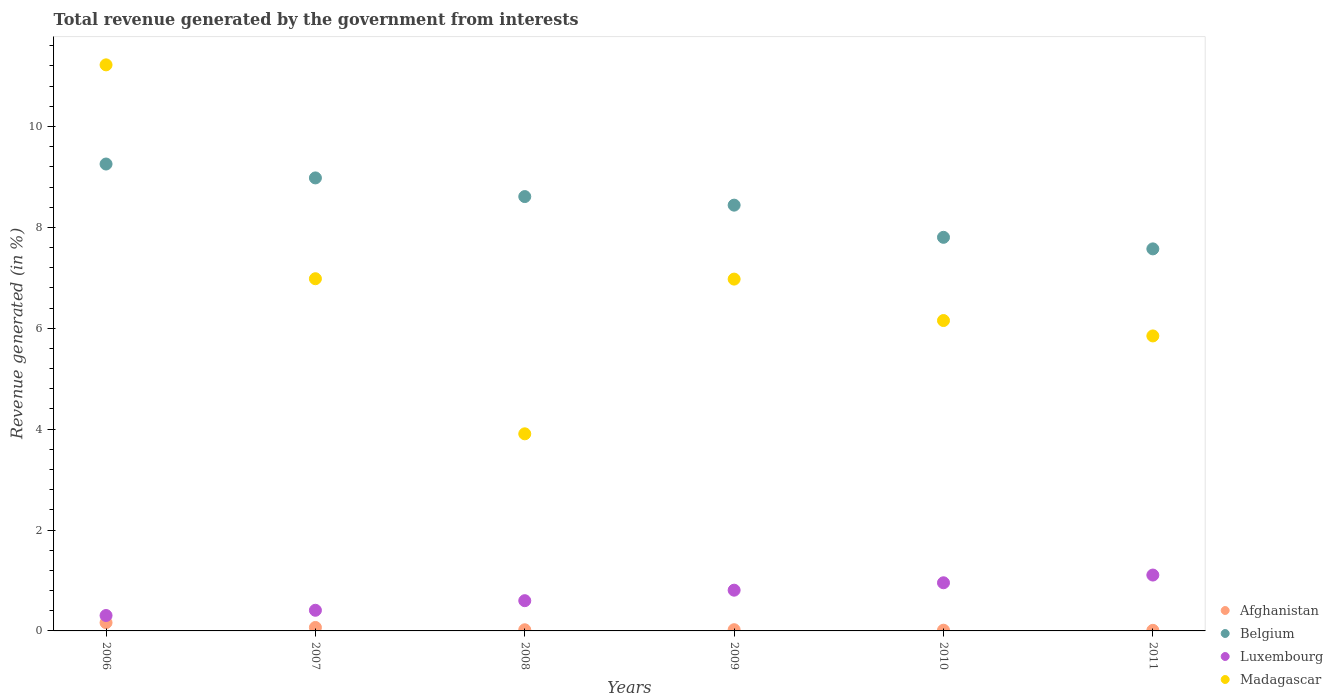What is the total revenue generated in Madagascar in 2008?
Your answer should be compact. 3.91. Across all years, what is the maximum total revenue generated in Madagascar?
Your answer should be very brief. 11.22. Across all years, what is the minimum total revenue generated in Belgium?
Keep it short and to the point. 7.57. In which year was the total revenue generated in Luxembourg maximum?
Your answer should be very brief. 2011. In which year was the total revenue generated in Madagascar minimum?
Provide a succinct answer. 2008. What is the total total revenue generated in Luxembourg in the graph?
Offer a very short reply. 4.18. What is the difference between the total revenue generated in Belgium in 2006 and that in 2011?
Make the answer very short. 1.68. What is the difference between the total revenue generated in Afghanistan in 2009 and the total revenue generated in Madagascar in 2008?
Keep it short and to the point. -3.88. What is the average total revenue generated in Afghanistan per year?
Ensure brevity in your answer.  0.05. In the year 2009, what is the difference between the total revenue generated in Belgium and total revenue generated in Luxembourg?
Ensure brevity in your answer.  7.63. In how many years, is the total revenue generated in Luxembourg greater than 2.4 %?
Offer a very short reply. 0. What is the ratio of the total revenue generated in Madagascar in 2006 to that in 2009?
Provide a succinct answer. 1.61. Is the total revenue generated in Belgium in 2009 less than that in 2011?
Provide a short and direct response. No. Is the difference between the total revenue generated in Belgium in 2006 and 2007 greater than the difference between the total revenue generated in Luxembourg in 2006 and 2007?
Make the answer very short. Yes. What is the difference between the highest and the second highest total revenue generated in Madagascar?
Ensure brevity in your answer.  4.24. What is the difference between the highest and the lowest total revenue generated in Belgium?
Your answer should be compact. 1.68. In how many years, is the total revenue generated in Belgium greater than the average total revenue generated in Belgium taken over all years?
Keep it short and to the point. 3. Is the sum of the total revenue generated in Belgium in 2008 and 2009 greater than the maximum total revenue generated in Luxembourg across all years?
Ensure brevity in your answer.  Yes. Is it the case that in every year, the sum of the total revenue generated in Madagascar and total revenue generated in Afghanistan  is greater than the sum of total revenue generated in Luxembourg and total revenue generated in Belgium?
Offer a very short reply. Yes. Does the total revenue generated in Belgium monotonically increase over the years?
Offer a terse response. No. Is the total revenue generated in Luxembourg strictly greater than the total revenue generated in Belgium over the years?
Provide a succinct answer. No. How many dotlines are there?
Provide a short and direct response. 4. How many years are there in the graph?
Provide a succinct answer. 6. What is the difference between two consecutive major ticks on the Y-axis?
Make the answer very short. 2. Are the values on the major ticks of Y-axis written in scientific E-notation?
Offer a very short reply. No. Does the graph contain grids?
Offer a terse response. No. Where does the legend appear in the graph?
Provide a succinct answer. Bottom right. What is the title of the graph?
Offer a very short reply. Total revenue generated by the government from interests. What is the label or title of the Y-axis?
Your response must be concise. Revenue generated (in %). What is the Revenue generated (in %) in Afghanistan in 2006?
Your answer should be compact. 0.16. What is the Revenue generated (in %) in Belgium in 2006?
Make the answer very short. 9.26. What is the Revenue generated (in %) of Luxembourg in 2006?
Your response must be concise. 0.31. What is the Revenue generated (in %) in Madagascar in 2006?
Keep it short and to the point. 11.22. What is the Revenue generated (in %) of Afghanistan in 2007?
Offer a terse response. 0.07. What is the Revenue generated (in %) of Belgium in 2007?
Your answer should be very brief. 8.98. What is the Revenue generated (in %) of Luxembourg in 2007?
Your response must be concise. 0.41. What is the Revenue generated (in %) of Madagascar in 2007?
Provide a succinct answer. 6.98. What is the Revenue generated (in %) in Afghanistan in 2008?
Offer a very short reply. 0.02. What is the Revenue generated (in %) in Belgium in 2008?
Ensure brevity in your answer.  8.61. What is the Revenue generated (in %) in Luxembourg in 2008?
Your response must be concise. 0.6. What is the Revenue generated (in %) of Madagascar in 2008?
Make the answer very short. 3.91. What is the Revenue generated (in %) in Afghanistan in 2009?
Provide a short and direct response. 0.02. What is the Revenue generated (in %) of Belgium in 2009?
Keep it short and to the point. 8.44. What is the Revenue generated (in %) of Luxembourg in 2009?
Your response must be concise. 0.81. What is the Revenue generated (in %) of Madagascar in 2009?
Give a very brief answer. 6.98. What is the Revenue generated (in %) of Afghanistan in 2010?
Ensure brevity in your answer.  0.01. What is the Revenue generated (in %) of Belgium in 2010?
Provide a short and direct response. 7.8. What is the Revenue generated (in %) of Luxembourg in 2010?
Your response must be concise. 0.95. What is the Revenue generated (in %) in Madagascar in 2010?
Provide a succinct answer. 6.15. What is the Revenue generated (in %) of Afghanistan in 2011?
Keep it short and to the point. 0.01. What is the Revenue generated (in %) of Belgium in 2011?
Your answer should be very brief. 7.57. What is the Revenue generated (in %) in Luxembourg in 2011?
Provide a short and direct response. 1.11. What is the Revenue generated (in %) of Madagascar in 2011?
Ensure brevity in your answer.  5.85. Across all years, what is the maximum Revenue generated (in %) of Afghanistan?
Keep it short and to the point. 0.16. Across all years, what is the maximum Revenue generated (in %) in Belgium?
Make the answer very short. 9.26. Across all years, what is the maximum Revenue generated (in %) of Luxembourg?
Your answer should be very brief. 1.11. Across all years, what is the maximum Revenue generated (in %) in Madagascar?
Provide a succinct answer. 11.22. Across all years, what is the minimum Revenue generated (in %) of Afghanistan?
Your response must be concise. 0.01. Across all years, what is the minimum Revenue generated (in %) in Belgium?
Provide a short and direct response. 7.57. Across all years, what is the minimum Revenue generated (in %) in Luxembourg?
Provide a short and direct response. 0.31. Across all years, what is the minimum Revenue generated (in %) of Madagascar?
Your answer should be very brief. 3.91. What is the total Revenue generated (in %) in Afghanistan in the graph?
Give a very brief answer. 0.31. What is the total Revenue generated (in %) of Belgium in the graph?
Make the answer very short. 50.67. What is the total Revenue generated (in %) of Luxembourg in the graph?
Provide a short and direct response. 4.18. What is the total Revenue generated (in %) of Madagascar in the graph?
Offer a very short reply. 41.09. What is the difference between the Revenue generated (in %) of Afghanistan in 2006 and that in 2007?
Offer a very short reply. 0.1. What is the difference between the Revenue generated (in %) in Belgium in 2006 and that in 2007?
Provide a short and direct response. 0.28. What is the difference between the Revenue generated (in %) in Luxembourg in 2006 and that in 2007?
Make the answer very short. -0.1. What is the difference between the Revenue generated (in %) in Madagascar in 2006 and that in 2007?
Offer a very short reply. 4.24. What is the difference between the Revenue generated (in %) in Afghanistan in 2006 and that in 2008?
Give a very brief answer. 0.14. What is the difference between the Revenue generated (in %) in Belgium in 2006 and that in 2008?
Offer a very short reply. 0.65. What is the difference between the Revenue generated (in %) in Luxembourg in 2006 and that in 2008?
Provide a short and direct response. -0.29. What is the difference between the Revenue generated (in %) in Madagascar in 2006 and that in 2008?
Make the answer very short. 7.32. What is the difference between the Revenue generated (in %) of Afghanistan in 2006 and that in 2009?
Keep it short and to the point. 0.14. What is the difference between the Revenue generated (in %) of Belgium in 2006 and that in 2009?
Make the answer very short. 0.82. What is the difference between the Revenue generated (in %) of Luxembourg in 2006 and that in 2009?
Give a very brief answer. -0.5. What is the difference between the Revenue generated (in %) of Madagascar in 2006 and that in 2009?
Ensure brevity in your answer.  4.25. What is the difference between the Revenue generated (in %) in Afghanistan in 2006 and that in 2010?
Offer a very short reply. 0.15. What is the difference between the Revenue generated (in %) in Belgium in 2006 and that in 2010?
Provide a succinct answer. 1.45. What is the difference between the Revenue generated (in %) in Luxembourg in 2006 and that in 2010?
Make the answer very short. -0.65. What is the difference between the Revenue generated (in %) of Madagascar in 2006 and that in 2010?
Make the answer very short. 5.07. What is the difference between the Revenue generated (in %) in Afghanistan in 2006 and that in 2011?
Provide a succinct answer. 0.15. What is the difference between the Revenue generated (in %) in Belgium in 2006 and that in 2011?
Provide a succinct answer. 1.68. What is the difference between the Revenue generated (in %) in Luxembourg in 2006 and that in 2011?
Provide a short and direct response. -0.8. What is the difference between the Revenue generated (in %) of Madagascar in 2006 and that in 2011?
Ensure brevity in your answer.  5.37. What is the difference between the Revenue generated (in %) of Afghanistan in 2007 and that in 2008?
Your response must be concise. 0.05. What is the difference between the Revenue generated (in %) in Belgium in 2007 and that in 2008?
Your answer should be compact. 0.37. What is the difference between the Revenue generated (in %) in Luxembourg in 2007 and that in 2008?
Offer a very short reply. -0.19. What is the difference between the Revenue generated (in %) in Madagascar in 2007 and that in 2008?
Your answer should be compact. 3.07. What is the difference between the Revenue generated (in %) of Afghanistan in 2007 and that in 2009?
Keep it short and to the point. 0.04. What is the difference between the Revenue generated (in %) in Belgium in 2007 and that in 2009?
Offer a very short reply. 0.54. What is the difference between the Revenue generated (in %) of Luxembourg in 2007 and that in 2009?
Your answer should be compact. -0.4. What is the difference between the Revenue generated (in %) in Madagascar in 2007 and that in 2009?
Keep it short and to the point. 0.01. What is the difference between the Revenue generated (in %) of Afghanistan in 2007 and that in 2010?
Keep it short and to the point. 0.05. What is the difference between the Revenue generated (in %) of Belgium in 2007 and that in 2010?
Give a very brief answer. 1.18. What is the difference between the Revenue generated (in %) of Luxembourg in 2007 and that in 2010?
Your answer should be compact. -0.55. What is the difference between the Revenue generated (in %) in Madagascar in 2007 and that in 2010?
Keep it short and to the point. 0.83. What is the difference between the Revenue generated (in %) of Afghanistan in 2007 and that in 2011?
Offer a very short reply. 0.06. What is the difference between the Revenue generated (in %) in Belgium in 2007 and that in 2011?
Give a very brief answer. 1.41. What is the difference between the Revenue generated (in %) in Luxembourg in 2007 and that in 2011?
Keep it short and to the point. -0.7. What is the difference between the Revenue generated (in %) in Madagascar in 2007 and that in 2011?
Make the answer very short. 1.13. What is the difference between the Revenue generated (in %) in Afghanistan in 2008 and that in 2009?
Keep it short and to the point. -0. What is the difference between the Revenue generated (in %) of Belgium in 2008 and that in 2009?
Offer a terse response. 0.17. What is the difference between the Revenue generated (in %) of Luxembourg in 2008 and that in 2009?
Make the answer very short. -0.21. What is the difference between the Revenue generated (in %) in Madagascar in 2008 and that in 2009?
Keep it short and to the point. -3.07. What is the difference between the Revenue generated (in %) in Afghanistan in 2008 and that in 2010?
Offer a very short reply. 0.01. What is the difference between the Revenue generated (in %) of Belgium in 2008 and that in 2010?
Your answer should be compact. 0.81. What is the difference between the Revenue generated (in %) of Luxembourg in 2008 and that in 2010?
Your response must be concise. -0.35. What is the difference between the Revenue generated (in %) of Madagascar in 2008 and that in 2010?
Offer a very short reply. -2.25. What is the difference between the Revenue generated (in %) of Afghanistan in 2008 and that in 2011?
Ensure brevity in your answer.  0.01. What is the difference between the Revenue generated (in %) in Belgium in 2008 and that in 2011?
Make the answer very short. 1.04. What is the difference between the Revenue generated (in %) in Luxembourg in 2008 and that in 2011?
Offer a very short reply. -0.51. What is the difference between the Revenue generated (in %) of Madagascar in 2008 and that in 2011?
Ensure brevity in your answer.  -1.94. What is the difference between the Revenue generated (in %) of Afghanistan in 2009 and that in 2010?
Provide a short and direct response. 0.01. What is the difference between the Revenue generated (in %) in Belgium in 2009 and that in 2010?
Your answer should be compact. 0.64. What is the difference between the Revenue generated (in %) in Luxembourg in 2009 and that in 2010?
Offer a terse response. -0.15. What is the difference between the Revenue generated (in %) in Madagascar in 2009 and that in 2010?
Offer a terse response. 0.82. What is the difference between the Revenue generated (in %) in Afghanistan in 2009 and that in 2011?
Make the answer very short. 0.01. What is the difference between the Revenue generated (in %) of Belgium in 2009 and that in 2011?
Provide a succinct answer. 0.87. What is the difference between the Revenue generated (in %) in Luxembourg in 2009 and that in 2011?
Offer a very short reply. -0.3. What is the difference between the Revenue generated (in %) of Madagascar in 2009 and that in 2011?
Your answer should be compact. 1.13. What is the difference between the Revenue generated (in %) in Afghanistan in 2010 and that in 2011?
Keep it short and to the point. 0. What is the difference between the Revenue generated (in %) in Belgium in 2010 and that in 2011?
Provide a short and direct response. 0.23. What is the difference between the Revenue generated (in %) in Luxembourg in 2010 and that in 2011?
Provide a short and direct response. -0.15. What is the difference between the Revenue generated (in %) in Madagascar in 2010 and that in 2011?
Ensure brevity in your answer.  0.3. What is the difference between the Revenue generated (in %) of Afghanistan in 2006 and the Revenue generated (in %) of Belgium in 2007?
Provide a short and direct response. -8.82. What is the difference between the Revenue generated (in %) in Afghanistan in 2006 and the Revenue generated (in %) in Luxembourg in 2007?
Give a very brief answer. -0.25. What is the difference between the Revenue generated (in %) in Afghanistan in 2006 and the Revenue generated (in %) in Madagascar in 2007?
Offer a terse response. -6.82. What is the difference between the Revenue generated (in %) of Belgium in 2006 and the Revenue generated (in %) of Luxembourg in 2007?
Offer a very short reply. 8.85. What is the difference between the Revenue generated (in %) in Belgium in 2006 and the Revenue generated (in %) in Madagascar in 2007?
Ensure brevity in your answer.  2.27. What is the difference between the Revenue generated (in %) in Luxembourg in 2006 and the Revenue generated (in %) in Madagascar in 2007?
Ensure brevity in your answer.  -6.68. What is the difference between the Revenue generated (in %) in Afghanistan in 2006 and the Revenue generated (in %) in Belgium in 2008?
Ensure brevity in your answer.  -8.45. What is the difference between the Revenue generated (in %) of Afghanistan in 2006 and the Revenue generated (in %) of Luxembourg in 2008?
Offer a terse response. -0.44. What is the difference between the Revenue generated (in %) of Afghanistan in 2006 and the Revenue generated (in %) of Madagascar in 2008?
Your answer should be compact. -3.74. What is the difference between the Revenue generated (in %) in Belgium in 2006 and the Revenue generated (in %) in Luxembourg in 2008?
Offer a terse response. 8.66. What is the difference between the Revenue generated (in %) of Belgium in 2006 and the Revenue generated (in %) of Madagascar in 2008?
Ensure brevity in your answer.  5.35. What is the difference between the Revenue generated (in %) in Luxembourg in 2006 and the Revenue generated (in %) in Madagascar in 2008?
Make the answer very short. -3.6. What is the difference between the Revenue generated (in %) in Afghanistan in 2006 and the Revenue generated (in %) in Belgium in 2009?
Make the answer very short. -8.28. What is the difference between the Revenue generated (in %) of Afghanistan in 2006 and the Revenue generated (in %) of Luxembourg in 2009?
Give a very brief answer. -0.64. What is the difference between the Revenue generated (in %) in Afghanistan in 2006 and the Revenue generated (in %) in Madagascar in 2009?
Keep it short and to the point. -6.81. What is the difference between the Revenue generated (in %) in Belgium in 2006 and the Revenue generated (in %) in Luxembourg in 2009?
Offer a terse response. 8.45. What is the difference between the Revenue generated (in %) in Belgium in 2006 and the Revenue generated (in %) in Madagascar in 2009?
Your answer should be very brief. 2.28. What is the difference between the Revenue generated (in %) in Luxembourg in 2006 and the Revenue generated (in %) in Madagascar in 2009?
Offer a very short reply. -6.67. What is the difference between the Revenue generated (in %) of Afghanistan in 2006 and the Revenue generated (in %) of Belgium in 2010?
Provide a succinct answer. -7.64. What is the difference between the Revenue generated (in %) of Afghanistan in 2006 and the Revenue generated (in %) of Luxembourg in 2010?
Give a very brief answer. -0.79. What is the difference between the Revenue generated (in %) of Afghanistan in 2006 and the Revenue generated (in %) of Madagascar in 2010?
Give a very brief answer. -5.99. What is the difference between the Revenue generated (in %) of Belgium in 2006 and the Revenue generated (in %) of Luxembourg in 2010?
Provide a succinct answer. 8.3. What is the difference between the Revenue generated (in %) in Belgium in 2006 and the Revenue generated (in %) in Madagascar in 2010?
Your answer should be very brief. 3.1. What is the difference between the Revenue generated (in %) of Luxembourg in 2006 and the Revenue generated (in %) of Madagascar in 2010?
Make the answer very short. -5.85. What is the difference between the Revenue generated (in %) in Afghanistan in 2006 and the Revenue generated (in %) in Belgium in 2011?
Your response must be concise. -7.41. What is the difference between the Revenue generated (in %) in Afghanistan in 2006 and the Revenue generated (in %) in Luxembourg in 2011?
Provide a succinct answer. -0.94. What is the difference between the Revenue generated (in %) of Afghanistan in 2006 and the Revenue generated (in %) of Madagascar in 2011?
Make the answer very short. -5.68. What is the difference between the Revenue generated (in %) of Belgium in 2006 and the Revenue generated (in %) of Luxembourg in 2011?
Make the answer very short. 8.15. What is the difference between the Revenue generated (in %) in Belgium in 2006 and the Revenue generated (in %) in Madagascar in 2011?
Your response must be concise. 3.41. What is the difference between the Revenue generated (in %) in Luxembourg in 2006 and the Revenue generated (in %) in Madagascar in 2011?
Ensure brevity in your answer.  -5.54. What is the difference between the Revenue generated (in %) of Afghanistan in 2007 and the Revenue generated (in %) of Belgium in 2008?
Offer a terse response. -8.54. What is the difference between the Revenue generated (in %) in Afghanistan in 2007 and the Revenue generated (in %) in Luxembourg in 2008?
Offer a terse response. -0.53. What is the difference between the Revenue generated (in %) in Afghanistan in 2007 and the Revenue generated (in %) in Madagascar in 2008?
Offer a very short reply. -3.84. What is the difference between the Revenue generated (in %) of Belgium in 2007 and the Revenue generated (in %) of Luxembourg in 2008?
Make the answer very short. 8.38. What is the difference between the Revenue generated (in %) of Belgium in 2007 and the Revenue generated (in %) of Madagascar in 2008?
Your response must be concise. 5.07. What is the difference between the Revenue generated (in %) in Luxembourg in 2007 and the Revenue generated (in %) in Madagascar in 2008?
Offer a terse response. -3.5. What is the difference between the Revenue generated (in %) of Afghanistan in 2007 and the Revenue generated (in %) of Belgium in 2009?
Provide a short and direct response. -8.37. What is the difference between the Revenue generated (in %) of Afghanistan in 2007 and the Revenue generated (in %) of Luxembourg in 2009?
Make the answer very short. -0.74. What is the difference between the Revenue generated (in %) of Afghanistan in 2007 and the Revenue generated (in %) of Madagascar in 2009?
Your answer should be compact. -6.91. What is the difference between the Revenue generated (in %) in Belgium in 2007 and the Revenue generated (in %) in Luxembourg in 2009?
Your response must be concise. 8.17. What is the difference between the Revenue generated (in %) in Belgium in 2007 and the Revenue generated (in %) in Madagascar in 2009?
Give a very brief answer. 2.01. What is the difference between the Revenue generated (in %) of Luxembourg in 2007 and the Revenue generated (in %) of Madagascar in 2009?
Ensure brevity in your answer.  -6.57. What is the difference between the Revenue generated (in %) in Afghanistan in 2007 and the Revenue generated (in %) in Belgium in 2010?
Keep it short and to the point. -7.73. What is the difference between the Revenue generated (in %) of Afghanistan in 2007 and the Revenue generated (in %) of Luxembourg in 2010?
Make the answer very short. -0.89. What is the difference between the Revenue generated (in %) of Afghanistan in 2007 and the Revenue generated (in %) of Madagascar in 2010?
Ensure brevity in your answer.  -6.08. What is the difference between the Revenue generated (in %) of Belgium in 2007 and the Revenue generated (in %) of Luxembourg in 2010?
Your answer should be very brief. 8.03. What is the difference between the Revenue generated (in %) of Belgium in 2007 and the Revenue generated (in %) of Madagascar in 2010?
Your response must be concise. 2.83. What is the difference between the Revenue generated (in %) in Luxembourg in 2007 and the Revenue generated (in %) in Madagascar in 2010?
Give a very brief answer. -5.74. What is the difference between the Revenue generated (in %) of Afghanistan in 2007 and the Revenue generated (in %) of Belgium in 2011?
Ensure brevity in your answer.  -7.51. What is the difference between the Revenue generated (in %) in Afghanistan in 2007 and the Revenue generated (in %) in Luxembourg in 2011?
Keep it short and to the point. -1.04. What is the difference between the Revenue generated (in %) in Afghanistan in 2007 and the Revenue generated (in %) in Madagascar in 2011?
Your response must be concise. -5.78. What is the difference between the Revenue generated (in %) in Belgium in 2007 and the Revenue generated (in %) in Luxembourg in 2011?
Offer a terse response. 7.87. What is the difference between the Revenue generated (in %) of Belgium in 2007 and the Revenue generated (in %) of Madagascar in 2011?
Your response must be concise. 3.13. What is the difference between the Revenue generated (in %) of Luxembourg in 2007 and the Revenue generated (in %) of Madagascar in 2011?
Ensure brevity in your answer.  -5.44. What is the difference between the Revenue generated (in %) of Afghanistan in 2008 and the Revenue generated (in %) of Belgium in 2009?
Provide a succinct answer. -8.42. What is the difference between the Revenue generated (in %) of Afghanistan in 2008 and the Revenue generated (in %) of Luxembourg in 2009?
Your answer should be compact. -0.78. What is the difference between the Revenue generated (in %) in Afghanistan in 2008 and the Revenue generated (in %) in Madagascar in 2009?
Make the answer very short. -6.95. What is the difference between the Revenue generated (in %) in Belgium in 2008 and the Revenue generated (in %) in Luxembourg in 2009?
Offer a terse response. 7.8. What is the difference between the Revenue generated (in %) in Belgium in 2008 and the Revenue generated (in %) in Madagascar in 2009?
Give a very brief answer. 1.64. What is the difference between the Revenue generated (in %) of Luxembourg in 2008 and the Revenue generated (in %) of Madagascar in 2009?
Keep it short and to the point. -6.38. What is the difference between the Revenue generated (in %) of Afghanistan in 2008 and the Revenue generated (in %) of Belgium in 2010?
Make the answer very short. -7.78. What is the difference between the Revenue generated (in %) in Afghanistan in 2008 and the Revenue generated (in %) in Luxembourg in 2010?
Provide a short and direct response. -0.93. What is the difference between the Revenue generated (in %) of Afghanistan in 2008 and the Revenue generated (in %) of Madagascar in 2010?
Provide a succinct answer. -6.13. What is the difference between the Revenue generated (in %) in Belgium in 2008 and the Revenue generated (in %) in Luxembourg in 2010?
Make the answer very short. 7.66. What is the difference between the Revenue generated (in %) in Belgium in 2008 and the Revenue generated (in %) in Madagascar in 2010?
Offer a very short reply. 2.46. What is the difference between the Revenue generated (in %) in Luxembourg in 2008 and the Revenue generated (in %) in Madagascar in 2010?
Make the answer very short. -5.55. What is the difference between the Revenue generated (in %) of Afghanistan in 2008 and the Revenue generated (in %) of Belgium in 2011?
Your response must be concise. -7.55. What is the difference between the Revenue generated (in %) in Afghanistan in 2008 and the Revenue generated (in %) in Luxembourg in 2011?
Keep it short and to the point. -1.08. What is the difference between the Revenue generated (in %) in Afghanistan in 2008 and the Revenue generated (in %) in Madagascar in 2011?
Ensure brevity in your answer.  -5.83. What is the difference between the Revenue generated (in %) of Belgium in 2008 and the Revenue generated (in %) of Luxembourg in 2011?
Provide a succinct answer. 7.5. What is the difference between the Revenue generated (in %) in Belgium in 2008 and the Revenue generated (in %) in Madagascar in 2011?
Provide a succinct answer. 2.76. What is the difference between the Revenue generated (in %) of Luxembourg in 2008 and the Revenue generated (in %) of Madagascar in 2011?
Offer a very short reply. -5.25. What is the difference between the Revenue generated (in %) of Afghanistan in 2009 and the Revenue generated (in %) of Belgium in 2010?
Give a very brief answer. -7.78. What is the difference between the Revenue generated (in %) of Afghanistan in 2009 and the Revenue generated (in %) of Luxembourg in 2010?
Provide a succinct answer. -0.93. What is the difference between the Revenue generated (in %) in Afghanistan in 2009 and the Revenue generated (in %) in Madagascar in 2010?
Ensure brevity in your answer.  -6.13. What is the difference between the Revenue generated (in %) in Belgium in 2009 and the Revenue generated (in %) in Luxembourg in 2010?
Give a very brief answer. 7.49. What is the difference between the Revenue generated (in %) in Belgium in 2009 and the Revenue generated (in %) in Madagascar in 2010?
Your answer should be very brief. 2.29. What is the difference between the Revenue generated (in %) in Luxembourg in 2009 and the Revenue generated (in %) in Madagascar in 2010?
Provide a succinct answer. -5.35. What is the difference between the Revenue generated (in %) in Afghanistan in 2009 and the Revenue generated (in %) in Belgium in 2011?
Give a very brief answer. -7.55. What is the difference between the Revenue generated (in %) in Afghanistan in 2009 and the Revenue generated (in %) in Luxembourg in 2011?
Give a very brief answer. -1.08. What is the difference between the Revenue generated (in %) of Afghanistan in 2009 and the Revenue generated (in %) of Madagascar in 2011?
Offer a very short reply. -5.82. What is the difference between the Revenue generated (in %) of Belgium in 2009 and the Revenue generated (in %) of Luxembourg in 2011?
Your answer should be very brief. 7.33. What is the difference between the Revenue generated (in %) in Belgium in 2009 and the Revenue generated (in %) in Madagascar in 2011?
Offer a terse response. 2.59. What is the difference between the Revenue generated (in %) of Luxembourg in 2009 and the Revenue generated (in %) of Madagascar in 2011?
Give a very brief answer. -5.04. What is the difference between the Revenue generated (in %) in Afghanistan in 2010 and the Revenue generated (in %) in Belgium in 2011?
Give a very brief answer. -7.56. What is the difference between the Revenue generated (in %) of Afghanistan in 2010 and the Revenue generated (in %) of Luxembourg in 2011?
Make the answer very short. -1.09. What is the difference between the Revenue generated (in %) in Afghanistan in 2010 and the Revenue generated (in %) in Madagascar in 2011?
Provide a succinct answer. -5.83. What is the difference between the Revenue generated (in %) in Belgium in 2010 and the Revenue generated (in %) in Luxembourg in 2011?
Your answer should be very brief. 6.7. What is the difference between the Revenue generated (in %) in Belgium in 2010 and the Revenue generated (in %) in Madagascar in 2011?
Your response must be concise. 1.95. What is the difference between the Revenue generated (in %) of Luxembourg in 2010 and the Revenue generated (in %) of Madagascar in 2011?
Your answer should be compact. -4.89. What is the average Revenue generated (in %) of Afghanistan per year?
Ensure brevity in your answer.  0.05. What is the average Revenue generated (in %) of Belgium per year?
Offer a very short reply. 8.44. What is the average Revenue generated (in %) in Luxembourg per year?
Ensure brevity in your answer.  0.7. What is the average Revenue generated (in %) of Madagascar per year?
Give a very brief answer. 6.85. In the year 2006, what is the difference between the Revenue generated (in %) of Afghanistan and Revenue generated (in %) of Belgium?
Your answer should be compact. -9.09. In the year 2006, what is the difference between the Revenue generated (in %) of Afghanistan and Revenue generated (in %) of Luxembourg?
Provide a succinct answer. -0.14. In the year 2006, what is the difference between the Revenue generated (in %) of Afghanistan and Revenue generated (in %) of Madagascar?
Provide a short and direct response. -11.06. In the year 2006, what is the difference between the Revenue generated (in %) of Belgium and Revenue generated (in %) of Luxembourg?
Keep it short and to the point. 8.95. In the year 2006, what is the difference between the Revenue generated (in %) in Belgium and Revenue generated (in %) in Madagascar?
Keep it short and to the point. -1.97. In the year 2006, what is the difference between the Revenue generated (in %) in Luxembourg and Revenue generated (in %) in Madagascar?
Your answer should be very brief. -10.92. In the year 2007, what is the difference between the Revenue generated (in %) of Afghanistan and Revenue generated (in %) of Belgium?
Provide a short and direct response. -8.91. In the year 2007, what is the difference between the Revenue generated (in %) in Afghanistan and Revenue generated (in %) in Luxembourg?
Offer a terse response. -0.34. In the year 2007, what is the difference between the Revenue generated (in %) in Afghanistan and Revenue generated (in %) in Madagascar?
Your response must be concise. -6.91. In the year 2007, what is the difference between the Revenue generated (in %) of Belgium and Revenue generated (in %) of Luxembourg?
Ensure brevity in your answer.  8.57. In the year 2007, what is the difference between the Revenue generated (in %) of Belgium and Revenue generated (in %) of Madagascar?
Provide a succinct answer. 2. In the year 2007, what is the difference between the Revenue generated (in %) of Luxembourg and Revenue generated (in %) of Madagascar?
Your answer should be very brief. -6.57. In the year 2008, what is the difference between the Revenue generated (in %) in Afghanistan and Revenue generated (in %) in Belgium?
Offer a terse response. -8.59. In the year 2008, what is the difference between the Revenue generated (in %) of Afghanistan and Revenue generated (in %) of Luxembourg?
Keep it short and to the point. -0.58. In the year 2008, what is the difference between the Revenue generated (in %) in Afghanistan and Revenue generated (in %) in Madagascar?
Your answer should be compact. -3.88. In the year 2008, what is the difference between the Revenue generated (in %) in Belgium and Revenue generated (in %) in Luxembourg?
Give a very brief answer. 8.01. In the year 2008, what is the difference between the Revenue generated (in %) in Belgium and Revenue generated (in %) in Madagascar?
Make the answer very short. 4.7. In the year 2008, what is the difference between the Revenue generated (in %) of Luxembourg and Revenue generated (in %) of Madagascar?
Offer a very short reply. -3.31. In the year 2009, what is the difference between the Revenue generated (in %) of Afghanistan and Revenue generated (in %) of Belgium?
Your answer should be very brief. -8.42. In the year 2009, what is the difference between the Revenue generated (in %) in Afghanistan and Revenue generated (in %) in Luxembourg?
Your answer should be very brief. -0.78. In the year 2009, what is the difference between the Revenue generated (in %) of Afghanistan and Revenue generated (in %) of Madagascar?
Offer a terse response. -6.95. In the year 2009, what is the difference between the Revenue generated (in %) in Belgium and Revenue generated (in %) in Luxembourg?
Your answer should be compact. 7.63. In the year 2009, what is the difference between the Revenue generated (in %) of Belgium and Revenue generated (in %) of Madagascar?
Your answer should be compact. 1.47. In the year 2009, what is the difference between the Revenue generated (in %) in Luxembourg and Revenue generated (in %) in Madagascar?
Your response must be concise. -6.17. In the year 2010, what is the difference between the Revenue generated (in %) in Afghanistan and Revenue generated (in %) in Belgium?
Make the answer very short. -7.79. In the year 2010, what is the difference between the Revenue generated (in %) of Afghanistan and Revenue generated (in %) of Luxembourg?
Your response must be concise. -0.94. In the year 2010, what is the difference between the Revenue generated (in %) in Afghanistan and Revenue generated (in %) in Madagascar?
Your response must be concise. -6.14. In the year 2010, what is the difference between the Revenue generated (in %) in Belgium and Revenue generated (in %) in Luxembourg?
Provide a succinct answer. 6.85. In the year 2010, what is the difference between the Revenue generated (in %) in Belgium and Revenue generated (in %) in Madagascar?
Ensure brevity in your answer.  1.65. In the year 2010, what is the difference between the Revenue generated (in %) in Luxembourg and Revenue generated (in %) in Madagascar?
Keep it short and to the point. -5.2. In the year 2011, what is the difference between the Revenue generated (in %) in Afghanistan and Revenue generated (in %) in Belgium?
Your response must be concise. -7.56. In the year 2011, what is the difference between the Revenue generated (in %) of Afghanistan and Revenue generated (in %) of Luxembourg?
Your answer should be very brief. -1.1. In the year 2011, what is the difference between the Revenue generated (in %) in Afghanistan and Revenue generated (in %) in Madagascar?
Give a very brief answer. -5.84. In the year 2011, what is the difference between the Revenue generated (in %) in Belgium and Revenue generated (in %) in Luxembourg?
Provide a short and direct response. 6.47. In the year 2011, what is the difference between the Revenue generated (in %) in Belgium and Revenue generated (in %) in Madagascar?
Provide a short and direct response. 1.73. In the year 2011, what is the difference between the Revenue generated (in %) of Luxembourg and Revenue generated (in %) of Madagascar?
Offer a terse response. -4.74. What is the ratio of the Revenue generated (in %) of Afghanistan in 2006 to that in 2007?
Provide a short and direct response. 2.39. What is the ratio of the Revenue generated (in %) in Belgium in 2006 to that in 2007?
Give a very brief answer. 1.03. What is the ratio of the Revenue generated (in %) in Luxembourg in 2006 to that in 2007?
Provide a succinct answer. 0.75. What is the ratio of the Revenue generated (in %) in Madagascar in 2006 to that in 2007?
Your response must be concise. 1.61. What is the ratio of the Revenue generated (in %) in Afghanistan in 2006 to that in 2008?
Make the answer very short. 7.2. What is the ratio of the Revenue generated (in %) in Belgium in 2006 to that in 2008?
Your answer should be compact. 1.07. What is the ratio of the Revenue generated (in %) in Luxembourg in 2006 to that in 2008?
Make the answer very short. 0.51. What is the ratio of the Revenue generated (in %) of Madagascar in 2006 to that in 2008?
Your response must be concise. 2.87. What is the ratio of the Revenue generated (in %) of Afghanistan in 2006 to that in 2009?
Keep it short and to the point. 6.79. What is the ratio of the Revenue generated (in %) of Belgium in 2006 to that in 2009?
Your answer should be very brief. 1.1. What is the ratio of the Revenue generated (in %) in Luxembourg in 2006 to that in 2009?
Your response must be concise. 0.38. What is the ratio of the Revenue generated (in %) in Madagascar in 2006 to that in 2009?
Offer a very short reply. 1.61. What is the ratio of the Revenue generated (in %) of Afghanistan in 2006 to that in 2010?
Make the answer very short. 11.5. What is the ratio of the Revenue generated (in %) of Belgium in 2006 to that in 2010?
Provide a short and direct response. 1.19. What is the ratio of the Revenue generated (in %) of Luxembourg in 2006 to that in 2010?
Ensure brevity in your answer.  0.32. What is the ratio of the Revenue generated (in %) in Madagascar in 2006 to that in 2010?
Provide a short and direct response. 1.82. What is the ratio of the Revenue generated (in %) in Afghanistan in 2006 to that in 2011?
Keep it short and to the point. 14.21. What is the ratio of the Revenue generated (in %) of Belgium in 2006 to that in 2011?
Give a very brief answer. 1.22. What is the ratio of the Revenue generated (in %) in Luxembourg in 2006 to that in 2011?
Ensure brevity in your answer.  0.28. What is the ratio of the Revenue generated (in %) in Madagascar in 2006 to that in 2011?
Ensure brevity in your answer.  1.92. What is the ratio of the Revenue generated (in %) in Afghanistan in 2007 to that in 2008?
Provide a short and direct response. 3.02. What is the ratio of the Revenue generated (in %) in Belgium in 2007 to that in 2008?
Offer a terse response. 1.04. What is the ratio of the Revenue generated (in %) of Luxembourg in 2007 to that in 2008?
Keep it short and to the point. 0.68. What is the ratio of the Revenue generated (in %) in Madagascar in 2007 to that in 2008?
Your response must be concise. 1.79. What is the ratio of the Revenue generated (in %) of Afghanistan in 2007 to that in 2009?
Offer a very short reply. 2.84. What is the ratio of the Revenue generated (in %) of Belgium in 2007 to that in 2009?
Your answer should be very brief. 1.06. What is the ratio of the Revenue generated (in %) of Luxembourg in 2007 to that in 2009?
Give a very brief answer. 0.51. What is the ratio of the Revenue generated (in %) of Madagascar in 2007 to that in 2009?
Keep it short and to the point. 1. What is the ratio of the Revenue generated (in %) in Afghanistan in 2007 to that in 2010?
Give a very brief answer. 4.82. What is the ratio of the Revenue generated (in %) in Belgium in 2007 to that in 2010?
Offer a very short reply. 1.15. What is the ratio of the Revenue generated (in %) of Luxembourg in 2007 to that in 2010?
Offer a terse response. 0.43. What is the ratio of the Revenue generated (in %) in Madagascar in 2007 to that in 2010?
Offer a very short reply. 1.13. What is the ratio of the Revenue generated (in %) of Afghanistan in 2007 to that in 2011?
Keep it short and to the point. 5.96. What is the ratio of the Revenue generated (in %) in Belgium in 2007 to that in 2011?
Keep it short and to the point. 1.19. What is the ratio of the Revenue generated (in %) in Luxembourg in 2007 to that in 2011?
Keep it short and to the point. 0.37. What is the ratio of the Revenue generated (in %) in Madagascar in 2007 to that in 2011?
Provide a succinct answer. 1.19. What is the ratio of the Revenue generated (in %) of Afghanistan in 2008 to that in 2009?
Provide a succinct answer. 0.94. What is the ratio of the Revenue generated (in %) in Belgium in 2008 to that in 2009?
Give a very brief answer. 1.02. What is the ratio of the Revenue generated (in %) of Luxembourg in 2008 to that in 2009?
Provide a short and direct response. 0.74. What is the ratio of the Revenue generated (in %) in Madagascar in 2008 to that in 2009?
Make the answer very short. 0.56. What is the ratio of the Revenue generated (in %) of Afghanistan in 2008 to that in 2010?
Give a very brief answer. 1.6. What is the ratio of the Revenue generated (in %) in Belgium in 2008 to that in 2010?
Offer a very short reply. 1.1. What is the ratio of the Revenue generated (in %) of Luxembourg in 2008 to that in 2010?
Give a very brief answer. 0.63. What is the ratio of the Revenue generated (in %) of Madagascar in 2008 to that in 2010?
Provide a short and direct response. 0.64. What is the ratio of the Revenue generated (in %) in Afghanistan in 2008 to that in 2011?
Your response must be concise. 1.97. What is the ratio of the Revenue generated (in %) in Belgium in 2008 to that in 2011?
Your answer should be compact. 1.14. What is the ratio of the Revenue generated (in %) in Luxembourg in 2008 to that in 2011?
Give a very brief answer. 0.54. What is the ratio of the Revenue generated (in %) in Madagascar in 2008 to that in 2011?
Provide a short and direct response. 0.67. What is the ratio of the Revenue generated (in %) of Afghanistan in 2009 to that in 2010?
Give a very brief answer. 1.7. What is the ratio of the Revenue generated (in %) in Belgium in 2009 to that in 2010?
Provide a succinct answer. 1.08. What is the ratio of the Revenue generated (in %) of Luxembourg in 2009 to that in 2010?
Ensure brevity in your answer.  0.85. What is the ratio of the Revenue generated (in %) in Madagascar in 2009 to that in 2010?
Keep it short and to the point. 1.13. What is the ratio of the Revenue generated (in %) in Afghanistan in 2009 to that in 2011?
Your response must be concise. 2.09. What is the ratio of the Revenue generated (in %) of Belgium in 2009 to that in 2011?
Your answer should be very brief. 1.11. What is the ratio of the Revenue generated (in %) in Luxembourg in 2009 to that in 2011?
Provide a short and direct response. 0.73. What is the ratio of the Revenue generated (in %) in Madagascar in 2009 to that in 2011?
Provide a succinct answer. 1.19. What is the ratio of the Revenue generated (in %) in Afghanistan in 2010 to that in 2011?
Offer a terse response. 1.24. What is the ratio of the Revenue generated (in %) of Belgium in 2010 to that in 2011?
Keep it short and to the point. 1.03. What is the ratio of the Revenue generated (in %) of Luxembourg in 2010 to that in 2011?
Make the answer very short. 0.86. What is the ratio of the Revenue generated (in %) in Madagascar in 2010 to that in 2011?
Keep it short and to the point. 1.05. What is the difference between the highest and the second highest Revenue generated (in %) in Afghanistan?
Make the answer very short. 0.1. What is the difference between the highest and the second highest Revenue generated (in %) of Belgium?
Ensure brevity in your answer.  0.28. What is the difference between the highest and the second highest Revenue generated (in %) of Luxembourg?
Provide a succinct answer. 0.15. What is the difference between the highest and the second highest Revenue generated (in %) of Madagascar?
Provide a succinct answer. 4.24. What is the difference between the highest and the lowest Revenue generated (in %) of Afghanistan?
Your answer should be very brief. 0.15. What is the difference between the highest and the lowest Revenue generated (in %) of Belgium?
Keep it short and to the point. 1.68. What is the difference between the highest and the lowest Revenue generated (in %) of Luxembourg?
Your answer should be compact. 0.8. What is the difference between the highest and the lowest Revenue generated (in %) of Madagascar?
Provide a succinct answer. 7.32. 